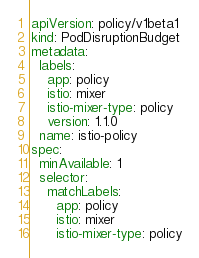Convert code to text. <code><loc_0><loc_0><loc_500><loc_500><_YAML_>apiVersion: policy/v1beta1
kind: PodDisruptionBudget
metadata:
  labels:
    app: policy
    istio: mixer
    istio-mixer-type: policy
    version: 1.1.0
  name: istio-policy
spec:
  minAvailable: 1
  selector:
    matchLabels:
      app: policy
      istio: mixer
      istio-mixer-type: policy
</code> 